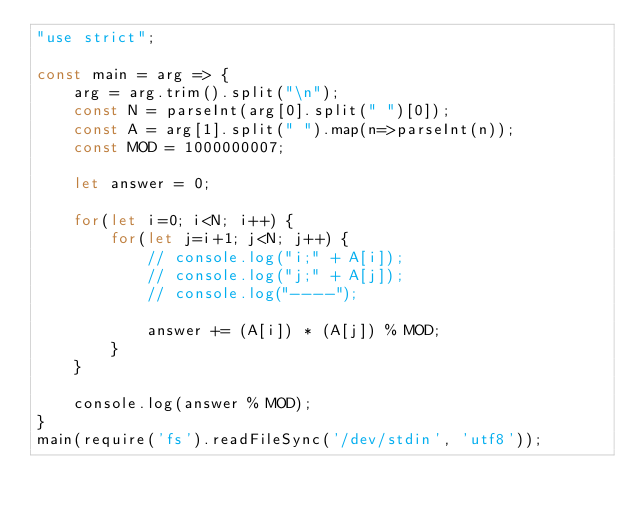Convert code to text. <code><loc_0><loc_0><loc_500><loc_500><_JavaScript_>"use strict";
    
const main = arg => {
    arg = arg.trim().split("\n");
    const N = parseInt(arg[0].split(" ")[0]);
    const A = arg[1].split(" ").map(n=>parseInt(n));
    const MOD = 1000000007;
    
    let answer = 0;
    
    for(let i=0; i<N; i++) {
        for(let j=i+1; j<N; j++) {
            // console.log("i;" + A[i]);
            // console.log("j;" + A[j]);
            // console.log("----");
            
            answer += (A[i]) * (A[j]) % MOD;
        }
    }
    
    console.log(answer % MOD);
}
main(require('fs').readFileSync('/dev/stdin', 'utf8'));</code> 